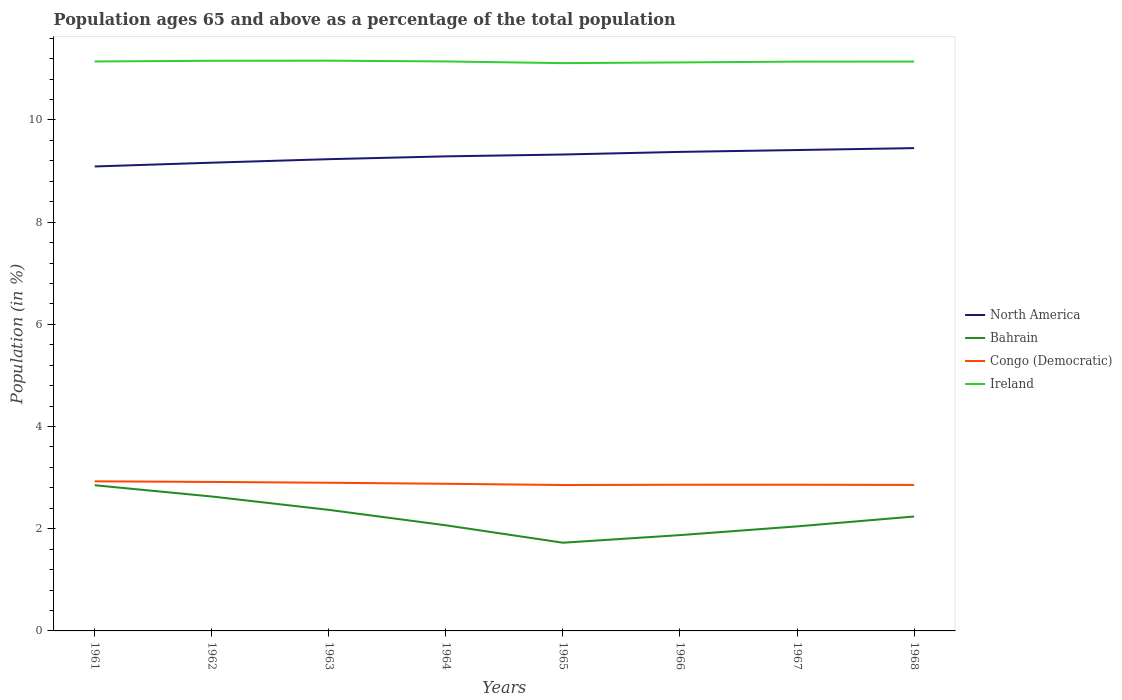Does the line corresponding to Bahrain intersect with the line corresponding to North America?
Offer a terse response. No. Is the number of lines equal to the number of legend labels?
Ensure brevity in your answer.  Yes. Across all years, what is the maximum percentage of the population ages 65 and above in Bahrain?
Your answer should be very brief. 1.73. In which year was the percentage of the population ages 65 and above in Ireland maximum?
Offer a very short reply. 1965. What is the total percentage of the population ages 65 and above in Ireland in the graph?
Offer a terse response. 0.02. What is the difference between the highest and the second highest percentage of the population ages 65 and above in Congo (Democratic)?
Your response must be concise. 0.07. What is the difference between the highest and the lowest percentage of the population ages 65 and above in Ireland?
Give a very brief answer. 6. How many years are there in the graph?
Offer a very short reply. 8. Does the graph contain any zero values?
Offer a terse response. No. How are the legend labels stacked?
Ensure brevity in your answer.  Vertical. What is the title of the graph?
Offer a terse response. Population ages 65 and above as a percentage of the total population. Does "Spain" appear as one of the legend labels in the graph?
Offer a terse response. No. What is the Population (in %) in North America in 1961?
Give a very brief answer. 9.09. What is the Population (in %) of Bahrain in 1961?
Provide a short and direct response. 2.85. What is the Population (in %) of Congo (Democratic) in 1961?
Give a very brief answer. 2.93. What is the Population (in %) of Ireland in 1961?
Provide a short and direct response. 11.14. What is the Population (in %) of North America in 1962?
Your response must be concise. 9.16. What is the Population (in %) in Bahrain in 1962?
Offer a very short reply. 2.63. What is the Population (in %) in Congo (Democratic) in 1962?
Ensure brevity in your answer.  2.92. What is the Population (in %) in Ireland in 1962?
Offer a very short reply. 11.16. What is the Population (in %) in North America in 1963?
Offer a very short reply. 9.23. What is the Population (in %) of Bahrain in 1963?
Your answer should be very brief. 2.37. What is the Population (in %) of Congo (Democratic) in 1963?
Offer a terse response. 2.9. What is the Population (in %) of Ireland in 1963?
Give a very brief answer. 11.16. What is the Population (in %) of North America in 1964?
Make the answer very short. 9.29. What is the Population (in %) in Bahrain in 1964?
Provide a short and direct response. 2.07. What is the Population (in %) of Congo (Democratic) in 1964?
Your answer should be compact. 2.88. What is the Population (in %) in Ireland in 1964?
Your answer should be compact. 11.15. What is the Population (in %) of North America in 1965?
Your answer should be compact. 9.32. What is the Population (in %) of Bahrain in 1965?
Your answer should be compact. 1.73. What is the Population (in %) of Congo (Democratic) in 1965?
Keep it short and to the point. 2.86. What is the Population (in %) of Ireland in 1965?
Make the answer very short. 11.11. What is the Population (in %) in North America in 1966?
Keep it short and to the point. 9.38. What is the Population (in %) of Bahrain in 1966?
Keep it short and to the point. 1.88. What is the Population (in %) in Congo (Democratic) in 1966?
Your answer should be compact. 2.86. What is the Population (in %) in Ireland in 1966?
Keep it short and to the point. 11.13. What is the Population (in %) of North America in 1967?
Provide a short and direct response. 9.41. What is the Population (in %) of Bahrain in 1967?
Offer a terse response. 2.05. What is the Population (in %) of Congo (Democratic) in 1967?
Offer a very short reply. 2.86. What is the Population (in %) of Ireland in 1967?
Your answer should be very brief. 11.14. What is the Population (in %) of North America in 1968?
Your response must be concise. 9.45. What is the Population (in %) in Bahrain in 1968?
Provide a short and direct response. 2.24. What is the Population (in %) of Congo (Democratic) in 1968?
Your response must be concise. 2.86. What is the Population (in %) in Ireland in 1968?
Your response must be concise. 11.14. Across all years, what is the maximum Population (in %) in North America?
Give a very brief answer. 9.45. Across all years, what is the maximum Population (in %) in Bahrain?
Give a very brief answer. 2.85. Across all years, what is the maximum Population (in %) in Congo (Democratic)?
Your answer should be very brief. 2.93. Across all years, what is the maximum Population (in %) in Ireland?
Offer a very short reply. 11.16. Across all years, what is the minimum Population (in %) in North America?
Offer a terse response. 9.09. Across all years, what is the minimum Population (in %) in Bahrain?
Your answer should be very brief. 1.73. Across all years, what is the minimum Population (in %) in Congo (Democratic)?
Provide a short and direct response. 2.86. Across all years, what is the minimum Population (in %) of Ireland?
Your response must be concise. 11.11. What is the total Population (in %) in North America in the graph?
Your answer should be compact. 74.33. What is the total Population (in %) of Bahrain in the graph?
Make the answer very short. 17.8. What is the total Population (in %) in Congo (Democratic) in the graph?
Provide a succinct answer. 23.06. What is the total Population (in %) of Ireland in the graph?
Your answer should be very brief. 89.13. What is the difference between the Population (in %) of North America in 1961 and that in 1962?
Provide a succinct answer. -0.07. What is the difference between the Population (in %) of Bahrain in 1961 and that in 1962?
Make the answer very short. 0.22. What is the difference between the Population (in %) in Congo (Democratic) in 1961 and that in 1962?
Give a very brief answer. 0.01. What is the difference between the Population (in %) in Ireland in 1961 and that in 1962?
Your response must be concise. -0.01. What is the difference between the Population (in %) in North America in 1961 and that in 1963?
Your answer should be very brief. -0.14. What is the difference between the Population (in %) of Bahrain in 1961 and that in 1963?
Provide a succinct answer. 0.48. What is the difference between the Population (in %) of Congo (Democratic) in 1961 and that in 1963?
Ensure brevity in your answer.  0.03. What is the difference between the Population (in %) in Ireland in 1961 and that in 1963?
Offer a terse response. -0.02. What is the difference between the Population (in %) in North America in 1961 and that in 1964?
Offer a terse response. -0.2. What is the difference between the Population (in %) of Bahrain in 1961 and that in 1964?
Give a very brief answer. 0.78. What is the difference between the Population (in %) of Congo (Democratic) in 1961 and that in 1964?
Ensure brevity in your answer.  0.05. What is the difference between the Population (in %) in Ireland in 1961 and that in 1964?
Provide a short and direct response. -0. What is the difference between the Population (in %) of North America in 1961 and that in 1965?
Your answer should be compact. -0.23. What is the difference between the Population (in %) in Bahrain in 1961 and that in 1965?
Offer a terse response. 1.13. What is the difference between the Population (in %) of Congo (Democratic) in 1961 and that in 1965?
Provide a short and direct response. 0.07. What is the difference between the Population (in %) of Ireland in 1961 and that in 1965?
Keep it short and to the point. 0.03. What is the difference between the Population (in %) of North America in 1961 and that in 1966?
Ensure brevity in your answer.  -0.29. What is the difference between the Population (in %) of Bahrain in 1961 and that in 1966?
Keep it short and to the point. 0.98. What is the difference between the Population (in %) of Congo (Democratic) in 1961 and that in 1966?
Your answer should be compact. 0.07. What is the difference between the Population (in %) in Ireland in 1961 and that in 1966?
Give a very brief answer. 0.02. What is the difference between the Population (in %) in North America in 1961 and that in 1967?
Your answer should be very brief. -0.32. What is the difference between the Population (in %) in Bahrain in 1961 and that in 1967?
Provide a short and direct response. 0.81. What is the difference between the Population (in %) in Congo (Democratic) in 1961 and that in 1967?
Keep it short and to the point. 0.07. What is the difference between the Population (in %) in Ireland in 1961 and that in 1967?
Offer a very short reply. 0. What is the difference between the Population (in %) in North America in 1961 and that in 1968?
Your response must be concise. -0.36. What is the difference between the Population (in %) of Bahrain in 1961 and that in 1968?
Provide a succinct answer. 0.61. What is the difference between the Population (in %) in Congo (Democratic) in 1961 and that in 1968?
Offer a very short reply. 0.07. What is the difference between the Population (in %) in Ireland in 1961 and that in 1968?
Offer a very short reply. 0. What is the difference between the Population (in %) in North America in 1962 and that in 1963?
Provide a short and direct response. -0.07. What is the difference between the Population (in %) in Bahrain in 1962 and that in 1963?
Your answer should be compact. 0.26. What is the difference between the Population (in %) in Congo (Democratic) in 1962 and that in 1963?
Your answer should be compact. 0.02. What is the difference between the Population (in %) of Ireland in 1962 and that in 1963?
Your answer should be very brief. -0. What is the difference between the Population (in %) of North America in 1962 and that in 1964?
Give a very brief answer. -0.12. What is the difference between the Population (in %) in Bahrain in 1962 and that in 1964?
Make the answer very short. 0.56. What is the difference between the Population (in %) in Congo (Democratic) in 1962 and that in 1964?
Offer a terse response. 0.04. What is the difference between the Population (in %) in Ireland in 1962 and that in 1964?
Make the answer very short. 0.01. What is the difference between the Population (in %) of North America in 1962 and that in 1965?
Offer a terse response. -0.16. What is the difference between the Population (in %) of Bahrain in 1962 and that in 1965?
Your answer should be very brief. 0.9. What is the difference between the Population (in %) in Congo (Democratic) in 1962 and that in 1965?
Give a very brief answer. 0.06. What is the difference between the Population (in %) of Ireland in 1962 and that in 1965?
Keep it short and to the point. 0.05. What is the difference between the Population (in %) of North America in 1962 and that in 1966?
Your answer should be compact. -0.21. What is the difference between the Population (in %) of Bahrain in 1962 and that in 1966?
Keep it short and to the point. 0.76. What is the difference between the Population (in %) of Congo (Democratic) in 1962 and that in 1966?
Ensure brevity in your answer.  0.06. What is the difference between the Population (in %) in Ireland in 1962 and that in 1966?
Make the answer very short. 0.03. What is the difference between the Population (in %) in North America in 1962 and that in 1967?
Make the answer very short. -0.25. What is the difference between the Population (in %) of Bahrain in 1962 and that in 1967?
Your answer should be compact. 0.58. What is the difference between the Population (in %) of Congo (Democratic) in 1962 and that in 1967?
Provide a succinct answer. 0.05. What is the difference between the Population (in %) of Ireland in 1962 and that in 1967?
Make the answer very short. 0.02. What is the difference between the Population (in %) in North America in 1962 and that in 1968?
Your response must be concise. -0.29. What is the difference between the Population (in %) of Bahrain in 1962 and that in 1968?
Your answer should be very brief. 0.39. What is the difference between the Population (in %) of Congo (Democratic) in 1962 and that in 1968?
Offer a terse response. 0.06. What is the difference between the Population (in %) in Ireland in 1962 and that in 1968?
Offer a very short reply. 0.02. What is the difference between the Population (in %) in North America in 1963 and that in 1964?
Provide a short and direct response. -0.06. What is the difference between the Population (in %) in Bahrain in 1963 and that in 1964?
Offer a terse response. 0.3. What is the difference between the Population (in %) of Congo (Democratic) in 1963 and that in 1964?
Your response must be concise. 0.02. What is the difference between the Population (in %) in Ireland in 1963 and that in 1964?
Your response must be concise. 0.01. What is the difference between the Population (in %) in North America in 1963 and that in 1965?
Make the answer very short. -0.09. What is the difference between the Population (in %) in Bahrain in 1963 and that in 1965?
Your answer should be compact. 0.64. What is the difference between the Population (in %) in Congo (Democratic) in 1963 and that in 1965?
Your response must be concise. 0.04. What is the difference between the Population (in %) in Ireland in 1963 and that in 1965?
Provide a short and direct response. 0.05. What is the difference between the Population (in %) of North America in 1963 and that in 1966?
Your answer should be compact. -0.14. What is the difference between the Population (in %) of Bahrain in 1963 and that in 1966?
Provide a succinct answer. 0.49. What is the difference between the Population (in %) in Congo (Democratic) in 1963 and that in 1966?
Give a very brief answer. 0.04. What is the difference between the Population (in %) of Ireland in 1963 and that in 1966?
Your response must be concise. 0.03. What is the difference between the Population (in %) of North America in 1963 and that in 1967?
Your response must be concise. -0.18. What is the difference between the Population (in %) of Bahrain in 1963 and that in 1967?
Make the answer very short. 0.32. What is the difference between the Population (in %) in Congo (Democratic) in 1963 and that in 1967?
Make the answer very short. 0.04. What is the difference between the Population (in %) of Ireland in 1963 and that in 1967?
Ensure brevity in your answer.  0.02. What is the difference between the Population (in %) in North America in 1963 and that in 1968?
Your response must be concise. -0.22. What is the difference between the Population (in %) of Bahrain in 1963 and that in 1968?
Your answer should be very brief. 0.13. What is the difference between the Population (in %) of Congo (Democratic) in 1963 and that in 1968?
Provide a succinct answer. 0.04. What is the difference between the Population (in %) in Ireland in 1963 and that in 1968?
Provide a short and direct response. 0.02. What is the difference between the Population (in %) in North America in 1964 and that in 1965?
Give a very brief answer. -0.04. What is the difference between the Population (in %) in Bahrain in 1964 and that in 1965?
Your answer should be compact. 0.34. What is the difference between the Population (in %) in Congo (Democratic) in 1964 and that in 1965?
Give a very brief answer. 0.02. What is the difference between the Population (in %) in Ireland in 1964 and that in 1965?
Keep it short and to the point. 0.03. What is the difference between the Population (in %) in North America in 1964 and that in 1966?
Give a very brief answer. -0.09. What is the difference between the Population (in %) of Bahrain in 1964 and that in 1966?
Ensure brevity in your answer.  0.19. What is the difference between the Population (in %) of Congo (Democratic) in 1964 and that in 1966?
Provide a short and direct response. 0.02. What is the difference between the Population (in %) in Ireland in 1964 and that in 1966?
Offer a very short reply. 0.02. What is the difference between the Population (in %) of North America in 1964 and that in 1967?
Your response must be concise. -0.12. What is the difference between the Population (in %) in Bahrain in 1964 and that in 1967?
Your answer should be very brief. 0.02. What is the difference between the Population (in %) in Congo (Democratic) in 1964 and that in 1967?
Offer a very short reply. 0.02. What is the difference between the Population (in %) in Ireland in 1964 and that in 1967?
Keep it short and to the point. 0. What is the difference between the Population (in %) in North America in 1964 and that in 1968?
Give a very brief answer. -0.16. What is the difference between the Population (in %) of Bahrain in 1964 and that in 1968?
Provide a short and direct response. -0.17. What is the difference between the Population (in %) in Congo (Democratic) in 1964 and that in 1968?
Offer a very short reply. 0.02. What is the difference between the Population (in %) in Ireland in 1964 and that in 1968?
Offer a very short reply. 0. What is the difference between the Population (in %) in North America in 1965 and that in 1966?
Give a very brief answer. -0.05. What is the difference between the Population (in %) in Bahrain in 1965 and that in 1966?
Provide a short and direct response. -0.15. What is the difference between the Population (in %) of Congo (Democratic) in 1965 and that in 1966?
Ensure brevity in your answer.  -0.01. What is the difference between the Population (in %) of Ireland in 1965 and that in 1966?
Provide a succinct answer. -0.01. What is the difference between the Population (in %) of North America in 1965 and that in 1967?
Give a very brief answer. -0.09. What is the difference between the Population (in %) in Bahrain in 1965 and that in 1967?
Ensure brevity in your answer.  -0.32. What is the difference between the Population (in %) of Congo (Democratic) in 1965 and that in 1967?
Offer a very short reply. -0.01. What is the difference between the Population (in %) of Ireland in 1965 and that in 1967?
Your answer should be compact. -0.03. What is the difference between the Population (in %) of North America in 1965 and that in 1968?
Keep it short and to the point. -0.13. What is the difference between the Population (in %) of Bahrain in 1965 and that in 1968?
Offer a terse response. -0.51. What is the difference between the Population (in %) of Congo (Democratic) in 1965 and that in 1968?
Give a very brief answer. -0. What is the difference between the Population (in %) in Ireland in 1965 and that in 1968?
Ensure brevity in your answer.  -0.03. What is the difference between the Population (in %) of North America in 1966 and that in 1967?
Offer a very short reply. -0.04. What is the difference between the Population (in %) in Bahrain in 1966 and that in 1967?
Offer a very short reply. -0.17. What is the difference between the Population (in %) of Congo (Democratic) in 1966 and that in 1967?
Ensure brevity in your answer.  -0. What is the difference between the Population (in %) in Ireland in 1966 and that in 1967?
Provide a succinct answer. -0.02. What is the difference between the Population (in %) of North America in 1966 and that in 1968?
Keep it short and to the point. -0.07. What is the difference between the Population (in %) in Bahrain in 1966 and that in 1968?
Your answer should be very brief. -0.36. What is the difference between the Population (in %) in Congo (Democratic) in 1966 and that in 1968?
Provide a short and direct response. 0. What is the difference between the Population (in %) of Ireland in 1966 and that in 1968?
Your answer should be very brief. -0.02. What is the difference between the Population (in %) in North America in 1967 and that in 1968?
Your answer should be compact. -0.04. What is the difference between the Population (in %) in Bahrain in 1967 and that in 1968?
Offer a very short reply. -0.19. What is the difference between the Population (in %) in Congo (Democratic) in 1967 and that in 1968?
Provide a short and direct response. 0. What is the difference between the Population (in %) in Ireland in 1967 and that in 1968?
Your response must be concise. -0. What is the difference between the Population (in %) of North America in 1961 and the Population (in %) of Bahrain in 1962?
Your response must be concise. 6.46. What is the difference between the Population (in %) in North America in 1961 and the Population (in %) in Congo (Democratic) in 1962?
Make the answer very short. 6.17. What is the difference between the Population (in %) of North America in 1961 and the Population (in %) of Ireland in 1962?
Provide a short and direct response. -2.07. What is the difference between the Population (in %) of Bahrain in 1961 and the Population (in %) of Congo (Democratic) in 1962?
Make the answer very short. -0.06. What is the difference between the Population (in %) in Bahrain in 1961 and the Population (in %) in Ireland in 1962?
Keep it short and to the point. -8.31. What is the difference between the Population (in %) in Congo (Democratic) in 1961 and the Population (in %) in Ireland in 1962?
Provide a short and direct response. -8.23. What is the difference between the Population (in %) of North America in 1961 and the Population (in %) of Bahrain in 1963?
Provide a succinct answer. 6.72. What is the difference between the Population (in %) in North America in 1961 and the Population (in %) in Congo (Democratic) in 1963?
Ensure brevity in your answer.  6.19. What is the difference between the Population (in %) of North America in 1961 and the Population (in %) of Ireland in 1963?
Ensure brevity in your answer.  -2.07. What is the difference between the Population (in %) in Bahrain in 1961 and the Population (in %) in Congo (Democratic) in 1963?
Offer a very short reply. -0.05. What is the difference between the Population (in %) in Bahrain in 1961 and the Population (in %) in Ireland in 1963?
Offer a very short reply. -8.31. What is the difference between the Population (in %) of Congo (Democratic) in 1961 and the Population (in %) of Ireland in 1963?
Ensure brevity in your answer.  -8.23. What is the difference between the Population (in %) in North America in 1961 and the Population (in %) in Bahrain in 1964?
Make the answer very short. 7.02. What is the difference between the Population (in %) in North America in 1961 and the Population (in %) in Congo (Democratic) in 1964?
Make the answer very short. 6.21. What is the difference between the Population (in %) in North America in 1961 and the Population (in %) in Ireland in 1964?
Offer a terse response. -2.06. What is the difference between the Population (in %) in Bahrain in 1961 and the Population (in %) in Congo (Democratic) in 1964?
Provide a succinct answer. -0.03. What is the difference between the Population (in %) of Bahrain in 1961 and the Population (in %) of Ireland in 1964?
Keep it short and to the point. -8.29. What is the difference between the Population (in %) of Congo (Democratic) in 1961 and the Population (in %) of Ireland in 1964?
Make the answer very short. -8.22. What is the difference between the Population (in %) in North America in 1961 and the Population (in %) in Bahrain in 1965?
Your answer should be very brief. 7.36. What is the difference between the Population (in %) in North America in 1961 and the Population (in %) in Congo (Democratic) in 1965?
Offer a very short reply. 6.23. What is the difference between the Population (in %) in North America in 1961 and the Population (in %) in Ireland in 1965?
Make the answer very short. -2.02. What is the difference between the Population (in %) of Bahrain in 1961 and the Population (in %) of Congo (Democratic) in 1965?
Offer a very short reply. -0. What is the difference between the Population (in %) in Bahrain in 1961 and the Population (in %) in Ireland in 1965?
Give a very brief answer. -8.26. What is the difference between the Population (in %) in Congo (Democratic) in 1961 and the Population (in %) in Ireland in 1965?
Provide a short and direct response. -8.18. What is the difference between the Population (in %) in North America in 1961 and the Population (in %) in Bahrain in 1966?
Your response must be concise. 7.21. What is the difference between the Population (in %) of North America in 1961 and the Population (in %) of Congo (Democratic) in 1966?
Keep it short and to the point. 6.23. What is the difference between the Population (in %) of North America in 1961 and the Population (in %) of Ireland in 1966?
Offer a terse response. -2.04. What is the difference between the Population (in %) in Bahrain in 1961 and the Population (in %) in Congo (Democratic) in 1966?
Provide a succinct answer. -0.01. What is the difference between the Population (in %) of Bahrain in 1961 and the Population (in %) of Ireland in 1966?
Provide a succinct answer. -8.27. What is the difference between the Population (in %) in Congo (Democratic) in 1961 and the Population (in %) in Ireland in 1966?
Your answer should be very brief. -8.2. What is the difference between the Population (in %) of North America in 1961 and the Population (in %) of Bahrain in 1967?
Provide a short and direct response. 7.04. What is the difference between the Population (in %) in North America in 1961 and the Population (in %) in Congo (Democratic) in 1967?
Your response must be concise. 6.23. What is the difference between the Population (in %) of North America in 1961 and the Population (in %) of Ireland in 1967?
Provide a short and direct response. -2.05. What is the difference between the Population (in %) in Bahrain in 1961 and the Population (in %) in Congo (Democratic) in 1967?
Provide a succinct answer. -0.01. What is the difference between the Population (in %) in Bahrain in 1961 and the Population (in %) in Ireland in 1967?
Your answer should be very brief. -8.29. What is the difference between the Population (in %) of Congo (Democratic) in 1961 and the Population (in %) of Ireland in 1967?
Your answer should be compact. -8.21. What is the difference between the Population (in %) of North America in 1961 and the Population (in %) of Bahrain in 1968?
Keep it short and to the point. 6.85. What is the difference between the Population (in %) of North America in 1961 and the Population (in %) of Congo (Democratic) in 1968?
Ensure brevity in your answer.  6.23. What is the difference between the Population (in %) of North America in 1961 and the Population (in %) of Ireland in 1968?
Offer a very short reply. -2.05. What is the difference between the Population (in %) in Bahrain in 1961 and the Population (in %) in Congo (Democratic) in 1968?
Keep it short and to the point. -0.01. What is the difference between the Population (in %) of Bahrain in 1961 and the Population (in %) of Ireland in 1968?
Offer a terse response. -8.29. What is the difference between the Population (in %) of Congo (Democratic) in 1961 and the Population (in %) of Ireland in 1968?
Offer a very short reply. -8.21. What is the difference between the Population (in %) in North America in 1962 and the Population (in %) in Bahrain in 1963?
Offer a very short reply. 6.79. What is the difference between the Population (in %) in North America in 1962 and the Population (in %) in Congo (Democratic) in 1963?
Offer a terse response. 6.26. What is the difference between the Population (in %) of North America in 1962 and the Population (in %) of Ireland in 1963?
Your response must be concise. -2. What is the difference between the Population (in %) in Bahrain in 1962 and the Population (in %) in Congo (Democratic) in 1963?
Keep it short and to the point. -0.27. What is the difference between the Population (in %) in Bahrain in 1962 and the Population (in %) in Ireland in 1963?
Make the answer very short. -8.53. What is the difference between the Population (in %) of Congo (Democratic) in 1962 and the Population (in %) of Ireland in 1963?
Your answer should be very brief. -8.24. What is the difference between the Population (in %) of North America in 1962 and the Population (in %) of Bahrain in 1964?
Make the answer very short. 7.1. What is the difference between the Population (in %) in North America in 1962 and the Population (in %) in Congo (Democratic) in 1964?
Your response must be concise. 6.28. What is the difference between the Population (in %) in North America in 1962 and the Population (in %) in Ireland in 1964?
Your response must be concise. -1.98. What is the difference between the Population (in %) of Bahrain in 1962 and the Population (in %) of Congo (Democratic) in 1964?
Ensure brevity in your answer.  -0.25. What is the difference between the Population (in %) in Bahrain in 1962 and the Population (in %) in Ireland in 1964?
Ensure brevity in your answer.  -8.51. What is the difference between the Population (in %) in Congo (Democratic) in 1962 and the Population (in %) in Ireland in 1964?
Offer a terse response. -8.23. What is the difference between the Population (in %) in North America in 1962 and the Population (in %) in Bahrain in 1965?
Keep it short and to the point. 7.44. What is the difference between the Population (in %) in North America in 1962 and the Population (in %) in Congo (Democratic) in 1965?
Offer a terse response. 6.31. What is the difference between the Population (in %) of North America in 1962 and the Population (in %) of Ireland in 1965?
Provide a short and direct response. -1.95. What is the difference between the Population (in %) of Bahrain in 1962 and the Population (in %) of Congo (Democratic) in 1965?
Provide a succinct answer. -0.22. What is the difference between the Population (in %) in Bahrain in 1962 and the Population (in %) in Ireland in 1965?
Your answer should be very brief. -8.48. What is the difference between the Population (in %) of Congo (Democratic) in 1962 and the Population (in %) of Ireland in 1965?
Your answer should be very brief. -8.2. What is the difference between the Population (in %) in North America in 1962 and the Population (in %) in Bahrain in 1966?
Ensure brevity in your answer.  7.29. What is the difference between the Population (in %) in North America in 1962 and the Population (in %) in Congo (Democratic) in 1966?
Ensure brevity in your answer.  6.3. What is the difference between the Population (in %) of North America in 1962 and the Population (in %) of Ireland in 1966?
Your response must be concise. -1.96. What is the difference between the Population (in %) of Bahrain in 1962 and the Population (in %) of Congo (Democratic) in 1966?
Make the answer very short. -0.23. What is the difference between the Population (in %) of Bahrain in 1962 and the Population (in %) of Ireland in 1966?
Offer a very short reply. -8.5. What is the difference between the Population (in %) of Congo (Democratic) in 1962 and the Population (in %) of Ireland in 1966?
Provide a short and direct response. -8.21. What is the difference between the Population (in %) of North America in 1962 and the Population (in %) of Bahrain in 1967?
Ensure brevity in your answer.  7.12. What is the difference between the Population (in %) in North America in 1962 and the Population (in %) in Congo (Democratic) in 1967?
Offer a terse response. 6.3. What is the difference between the Population (in %) of North America in 1962 and the Population (in %) of Ireland in 1967?
Provide a short and direct response. -1.98. What is the difference between the Population (in %) in Bahrain in 1962 and the Population (in %) in Congo (Democratic) in 1967?
Provide a short and direct response. -0.23. What is the difference between the Population (in %) of Bahrain in 1962 and the Population (in %) of Ireland in 1967?
Keep it short and to the point. -8.51. What is the difference between the Population (in %) of Congo (Democratic) in 1962 and the Population (in %) of Ireland in 1967?
Ensure brevity in your answer.  -8.23. What is the difference between the Population (in %) of North America in 1962 and the Population (in %) of Bahrain in 1968?
Make the answer very short. 6.92. What is the difference between the Population (in %) in North America in 1962 and the Population (in %) in Congo (Democratic) in 1968?
Make the answer very short. 6.31. What is the difference between the Population (in %) in North America in 1962 and the Population (in %) in Ireland in 1968?
Provide a succinct answer. -1.98. What is the difference between the Population (in %) of Bahrain in 1962 and the Population (in %) of Congo (Democratic) in 1968?
Make the answer very short. -0.23. What is the difference between the Population (in %) in Bahrain in 1962 and the Population (in %) in Ireland in 1968?
Make the answer very short. -8.51. What is the difference between the Population (in %) of Congo (Democratic) in 1962 and the Population (in %) of Ireland in 1968?
Provide a succinct answer. -8.23. What is the difference between the Population (in %) of North America in 1963 and the Population (in %) of Bahrain in 1964?
Your answer should be compact. 7.17. What is the difference between the Population (in %) of North America in 1963 and the Population (in %) of Congo (Democratic) in 1964?
Ensure brevity in your answer.  6.35. What is the difference between the Population (in %) in North America in 1963 and the Population (in %) in Ireland in 1964?
Your answer should be compact. -1.91. What is the difference between the Population (in %) of Bahrain in 1963 and the Population (in %) of Congo (Democratic) in 1964?
Give a very brief answer. -0.51. What is the difference between the Population (in %) in Bahrain in 1963 and the Population (in %) in Ireland in 1964?
Offer a terse response. -8.78. What is the difference between the Population (in %) in Congo (Democratic) in 1963 and the Population (in %) in Ireland in 1964?
Give a very brief answer. -8.25. What is the difference between the Population (in %) of North America in 1963 and the Population (in %) of Bahrain in 1965?
Make the answer very short. 7.51. What is the difference between the Population (in %) of North America in 1963 and the Population (in %) of Congo (Democratic) in 1965?
Offer a terse response. 6.38. What is the difference between the Population (in %) of North America in 1963 and the Population (in %) of Ireland in 1965?
Provide a succinct answer. -1.88. What is the difference between the Population (in %) in Bahrain in 1963 and the Population (in %) in Congo (Democratic) in 1965?
Keep it short and to the point. -0.49. What is the difference between the Population (in %) of Bahrain in 1963 and the Population (in %) of Ireland in 1965?
Offer a very short reply. -8.74. What is the difference between the Population (in %) of Congo (Democratic) in 1963 and the Population (in %) of Ireland in 1965?
Your response must be concise. -8.21. What is the difference between the Population (in %) of North America in 1963 and the Population (in %) of Bahrain in 1966?
Offer a terse response. 7.36. What is the difference between the Population (in %) of North America in 1963 and the Population (in %) of Congo (Democratic) in 1966?
Keep it short and to the point. 6.37. What is the difference between the Population (in %) of North America in 1963 and the Population (in %) of Ireland in 1966?
Keep it short and to the point. -1.89. What is the difference between the Population (in %) in Bahrain in 1963 and the Population (in %) in Congo (Democratic) in 1966?
Ensure brevity in your answer.  -0.49. What is the difference between the Population (in %) in Bahrain in 1963 and the Population (in %) in Ireland in 1966?
Provide a short and direct response. -8.76. What is the difference between the Population (in %) of Congo (Democratic) in 1963 and the Population (in %) of Ireland in 1966?
Provide a short and direct response. -8.23. What is the difference between the Population (in %) of North America in 1963 and the Population (in %) of Bahrain in 1967?
Your answer should be compact. 7.19. What is the difference between the Population (in %) in North America in 1963 and the Population (in %) in Congo (Democratic) in 1967?
Make the answer very short. 6.37. What is the difference between the Population (in %) in North America in 1963 and the Population (in %) in Ireland in 1967?
Make the answer very short. -1.91. What is the difference between the Population (in %) in Bahrain in 1963 and the Population (in %) in Congo (Democratic) in 1967?
Your response must be concise. -0.49. What is the difference between the Population (in %) of Bahrain in 1963 and the Population (in %) of Ireland in 1967?
Offer a very short reply. -8.77. What is the difference between the Population (in %) of Congo (Democratic) in 1963 and the Population (in %) of Ireland in 1967?
Make the answer very short. -8.24. What is the difference between the Population (in %) in North America in 1963 and the Population (in %) in Bahrain in 1968?
Offer a very short reply. 6.99. What is the difference between the Population (in %) of North America in 1963 and the Population (in %) of Congo (Democratic) in 1968?
Your response must be concise. 6.38. What is the difference between the Population (in %) in North America in 1963 and the Population (in %) in Ireland in 1968?
Your answer should be compact. -1.91. What is the difference between the Population (in %) of Bahrain in 1963 and the Population (in %) of Congo (Democratic) in 1968?
Provide a short and direct response. -0.49. What is the difference between the Population (in %) in Bahrain in 1963 and the Population (in %) in Ireland in 1968?
Provide a short and direct response. -8.77. What is the difference between the Population (in %) in Congo (Democratic) in 1963 and the Population (in %) in Ireland in 1968?
Give a very brief answer. -8.24. What is the difference between the Population (in %) of North America in 1964 and the Population (in %) of Bahrain in 1965?
Offer a very short reply. 7.56. What is the difference between the Population (in %) in North America in 1964 and the Population (in %) in Congo (Democratic) in 1965?
Make the answer very short. 6.43. What is the difference between the Population (in %) in North America in 1964 and the Population (in %) in Ireland in 1965?
Provide a short and direct response. -1.82. What is the difference between the Population (in %) in Bahrain in 1964 and the Population (in %) in Congo (Democratic) in 1965?
Your response must be concise. -0.79. What is the difference between the Population (in %) of Bahrain in 1964 and the Population (in %) of Ireland in 1965?
Your answer should be compact. -9.04. What is the difference between the Population (in %) in Congo (Democratic) in 1964 and the Population (in %) in Ireland in 1965?
Provide a short and direct response. -8.23. What is the difference between the Population (in %) in North America in 1964 and the Population (in %) in Bahrain in 1966?
Offer a very short reply. 7.41. What is the difference between the Population (in %) in North America in 1964 and the Population (in %) in Congo (Democratic) in 1966?
Your response must be concise. 6.43. What is the difference between the Population (in %) in North America in 1964 and the Population (in %) in Ireland in 1966?
Offer a terse response. -1.84. What is the difference between the Population (in %) in Bahrain in 1964 and the Population (in %) in Congo (Democratic) in 1966?
Give a very brief answer. -0.79. What is the difference between the Population (in %) of Bahrain in 1964 and the Population (in %) of Ireland in 1966?
Your answer should be very brief. -9.06. What is the difference between the Population (in %) of Congo (Democratic) in 1964 and the Population (in %) of Ireland in 1966?
Ensure brevity in your answer.  -8.25. What is the difference between the Population (in %) in North America in 1964 and the Population (in %) in Bahrain in 1967?
Offer a very short reply. 7.24. What is the difference between the Population (in %) in North America in 1964 and the Population (in %) in Congo (Democratic) in 1967?
Make the answer very short. 6.43. What is the difference between the Population (in %) of North America in 1964 and the Population (in %) of Ireland in 1967?
Give a very brief answer. -1.85. What is the difference between the Population (in %) of Bahrain in 1964 and the Population (in %) of Congo (Democratic) in 1967?
Make the answer very short. -0.79. What is the difference between the Population (in %) in Bahrain in 1964 and the Population (in %) in Ireland in 1967?
Offer a very short reply. -9.07. What is the difference between the Population (in %) in Congo (Democratic) in 1964 and the Population (in %) in Ireland in 1967?
Your answer should be compact. -8.26. What is the difference between the Population (in %) in North America in 1964 and the Population (in %) in Bahrain in 1968?
Provide a succinct answer. 7.05. What is the difference between the Population (in %) of North America in 1964 and the Population (in %) of Congo (Democratic) in 1968?
Provide a short and direct response. 6.43. What is the difference between the Population (in %) in North America in 1964 and the Population (in %) in Ireland in 1968?
Your answer should be compact. -1.85. What is the difference between the Population (in %) of Bahrain in 1964 and the Population (in %) of Congo (Democratic) in 1968?
Provide a succinct answer. -0.79. What is the difference between the Population (in %) of Bahrain in 1964 and the Population (in %) of Ireland in 1968?
Make the answer very short. -9.08. What is the difference between the Population (in %) of Congo (Democratic) in 1964 and the Population (in %) of Ireland in 1968?
Offer a very short reply. -8.26. What is the difference between the Population (in %) in North America in 1965 and the Population (in %) in Bahrain in 1966?
Offer a terse response. 7.45. What is the difference between the Population (in %) in North America in 1965 and the Population (in %) in Congo (Democratic) in 1966?
Offer a very short reply. 6.46. What is the difference between the Population (in %) of North America in 1965 and the Population (in %) of Ireland in 1966?
Make the answer very short. -1.8. What is the difference between the Population (in %) in Bahrain in 1965 and the Population (in %) in Congo (Democratic) in 1966?
Make the answer very short. -1.13. What is the difference between the Population (in %) in Bahrain in 1965 and the Population (in %) in Ireland in 1966?
Give a very brief answer. -9.4. What is the difference between the Population (in %) of Congo (Democratic) in 1965 and the Population (in %) of Ireland in 1966?
Give a very brief answer. -8.27. What is the difference between the Population (in %) in North America in 1965 and the Population (in %) in Bahrain in 1967?
Your response must be concise. 7.28. What is the difference between the Population (in %) in North America in 1965 and the Population (in %) in Congo (Democratic) in 1967?
Provide a short and direct response. 6.46. What is the difference between the Population (in %) of North America in 1965 and the Population (in %) of Ireland in 1967?
Your answer should be very brief. -1.82. What is the difference between the Population (in %) in Bahrain in 1965 and the Population (in %) in Congo (Democratic) in 1967?
Keep it short and to the point. -1.13. What is the difference between the Population (in %) in Bahrain in 1965 and the Population (in %) in Ireland in 1967?
Offer a terse response. -9.42. What is the difference between the Population (in %) in Congo (Democratic) in 1965 and the Population (in %) in Ireland in 1967?
Give a very brief answer. -8.29. What is the difference between the Population (in %) of North America in 1965 and the Population (in %) of Bahrain in 1968?
Provide a short and direct response. 7.08. What is the difference between the Population (in %) of North America in 1965 and the Population (in %) of Congo (Democratic) in 1968?
Provide a short and direct response. 6.47. What is the difference between the Population (in %) in North America in 1965 and the Population (in %) in Ireland in 1968?
Provide a short and direct response. -1.82. What is the difference between the Population (in %) in Bahrain in 1965 and the Population (in %) in Congo (Democratic) in 1968?
Your answer should be very brief. -1.13. What is the difference between the Population (in %) in Bahrain in 1965 and the Population (in %) in Ireland in 1968?
Your answer should be very brief. -9.42. What is the difference between the Population (in %) in Congo (Democratic) in 1965 and the Population (in %) in Ireland in 1968?
Give a very brief answer. -8.29. What is the difference between the Population (in %) in North America in 1966 and the Population (in %) in Bahrain in 1967?
Ensure brevity in your answer.  7.33. What is the difference between the Population (in %) in North America in 1966 and the Population (in %) in Congo (Democratic) in 1967?
Your answer should be compact. 6.51. What is the difference between the Population (in %) of North America in 1966 and the Population (in %) of Ireland in 1967?
Keep it short and to the point. -1.77. What is the difference between the Population (in %) of Bahrain in 1966 and the Population (in %) of Congo (Democratic) in 1967?
Offer a terse response. -0.99. What is the difference between the Population (in %) of Bahrain in 1966 and the Population (in %) of Ireland in 1967?
Your response must be concise. -9.27. What is the difference between the Population (in %) of Congo (Democratic) in 1966 and the Population (in %) of Ireland in 1967?
Provide a succinct answer. -8.28. What is the difference between the Population (in %) in North America in 1966 and the Population (in %) in Bahrain in 1968?
Your answer should be compact. 7.14. What is the difference between the Population (in %) of North America in 1966 and the Population (in %) of Congo (Democratic) in 1968?
Provide a succinct answer. 6.52. What is the difference between the Population (in %) of North America in 1966 and the Population (in %) of Ireland in 1968?
Offer a terse response. -1.77. What is the difference between the Population (in %) in Bahrain in 1966 and the Population (in %) in Congo (Democratic) in 1968?
Your response must be concise. -0.98. What is the difference between the Population (in %) of Bahrain in 1966 and the Population (in %) of Ireland in 1968?
Your response must be concise. -9.27. What is the difference between the Population (in %) in Congo (Democratic) in 1966 and the Population (in %) in Ireland in 1968?
Your response must be concise. -8.28. What is the difference between the Population (in %) of North America in 1967 and the Population (in %) of Bahrain in 1968?
Your answer should be compact. 7.17. What is the difference between the Population (in %) of North America in 1967 and the Population (in %) of Congo (Democratic) in 1968?
Give a very brief answer. 6.55. What is the difference between the Population (in %) in North America in 1967 and the Population (in %) in Ireland in 1968?
Make the answer very short. -1.73. What is the difference between the Population (in %) in Bahrain in 1967 and the Population (in %) in Congo (Democratic) in 1968?
Make the answer very short. -0.81. What is the difference between the Population (in %) of Bahrain in 1967 and the Population (in %) of Ireland in 1968?
Provide a succinct answer. -9.1. What is the difference between the Population (in %) of Congo (Democratic) in 1967 and the Population (in %) of Ireland in 1968?
Offer a terse response. -8.28. What is the average Population (in %) in North America per year?
Make the answer very short. 9.29. What is the average Population (in %) of Bahrain per year?
Your answer should be compact. 2.23. What is the average Population (in %) of Congo (Democratic) per year?
Keep it short and to the point. 2.88. What is the average Population (in %) in Ireland per year?
Your answer should be compact. 11.14. In the year 1961, what is the difference between the Population (in %) of North America and Population (in %) of Bahrain?
Provide a short and direct response. 6.24. In the year 1961, what is the difference between the Population (in %) in North America and Population (in %) in Congo (Democratic)?
Provide a succinct answer. 6.16. In the year 1961, what is the difference between the Population (in %) in North America and Population (in %) in Ireland?
Provide a short and direct response. -2.05. In the year 1961, what is the difference between the Population (in %) of Bahrain and Population (in %) of Congo (Democratic)?
Your response must be concise. -0.08. In the year 1961, what is the difference between the Population (in %) of Bahrain and Population (in %) of Ireland?
Offer a terse response. -8.29. In the year 1961, what is the difference between the Population (in %) of Congo (Democratic) and Population (in %) of Ireland?
Keep it short and to the point. -8.22. In the year 1962, what is the difference between the Population (in %) of North America and Population (in %) of Bahrain?
Make the answer very short. 6.53. In the year 1962, what is the difference between the Population (in %) in North America and Population (in %) in Congo (Democratic)?
Ensure brevity in your answer.  6.25. In the year 1962, what is the difference between the Population (in %) of North America and Population (in %) of Ireland?
Ensure brevity in your answer.  -1.99. In the year 1962, what is the difference between the Population (in %) in Bahrain and Population (in %) in Congo (Democratic)?
Offer a very short reply. -0.29. In the year 1962, what is the difference between the Population (in %) in Bahrain and Population (in %) in Ireland?
Make the answer very short. -8.53. In the year 1962, what is the difference between the Population (in %) in Congo (Democratic) and Population (in %) in Ireland?
Provide a short and direct response. -8.24. In the year 1963, what is the difference between the Population (in %) in North America and Population (in %) in Bahrain?
Your answer should be very brief. 6.86. In the year 1963, what is the difference between the Population (in %) in North America and Population (in %) in Congo (Democratic)?
Provide a short and direct response. 6.33. In the year 1963, what is the difference between the Population (in %) in North America and Population (in %) in Ireland?
Give a very brief answer. -1.93. In the year 1963, what is the difference between the Population (in %) of Bahrain and Population (in %) of Congo (Democratic)?
Ensure brevity in your answer.  -0.53. In the year 1963, what is the difference between the Population (in %) of Bahrain and Population (in %) of Ireland?
Your response must be concise. -8.79. In the year 1963, what is the difference between the Population (in %) in Congo (Democratic) and Population (in %) in Ireland?
Provide a succinct answer. -8.26. In the year 1964, what is the difference between the Population (in %) in North America and Population (in %) in Bahrain?
Provide a succinct answer. 7.22. In the year 1964, what is the difference between the Population (in %) in North America and Population (in %) in Congo (Democratic)?
Your response must be concise. 6.41. In the year 1964, what is the difference between the Population (in %) in North America and Population (in %) in Ireland?
Ensure brevity in your answer.  -1.86. In the year 1964, what is the difference between the Population (in %) in Bahrain and Population (in %) in Congo (Democratic)?
Provide a succinct answer. -0.81. In the year 1964, what is the difference between the Population (in %) of Bahrain and Population (in %) of Ireland?
Your answer should be compact. -9.08. In the year 1964, what is the difference between the Population (in %) of Congo (Democratic) and Population (in %) of Ireland?
Your answer should be very brief. -8.27. In the year 1965, what is the difference between the Population (in %) of North America and Population (in %) of Bahrain?
Your answer should be compact. 7.6. In the year 1965, what is the difference between the Population (in %) in North America and Population (in %) in Congo (Democratic)?
Your response must be concise. 6.47. In the year 1965, what is the difference between the Population (in %) in North America and Population (in %) in Ireland?
Your answer should be compact. -1.79. In the year 1965, what is the difference between the Population (in %) of Bahrain and Population (in %) of Congo (Democratic)?
Provide a succinct answer. -1.13. In the year 1965, what is the difference between the Population (in %) of Bahrain and Population (in %) of Ireland?
Ensure brevity in your answer.  -9.39. In the year 1965, what is the difference between the Population (in %) in Congo (Democratic) and Population (in %) in Ireland?
Your response must be concise. -8.26. In the year 1966, what is the difference between the Population (in %) of North America and Population (in %) of Bahrain?
Provide a succinct answer. 7.5. In the year 1966, what is the difference between the Population (in %) in North America and Population (in %) in Congo (Democratic)?
Make the answer very short. 6.51. In the year 1966, what is the difference between the Population (in %) of North America and Population (in %) of Ireland?
Offer a terse response. -1.75. In the year 1966, what is the difference between the Population (in %) in Bahrain and Population (in %) in Congo (Democratic)?
Your answer should be compact. -0.99. In the year 1966, what is the difference between the Population (in %) of Bahrain and Population (in %) of Ireland?
Give a very brief answer. -9.25. In the year 1966, what is the difference between the Population (in %) in Congo (Democratic) and Population (in %) in Ireland?
Your response must be concise. -8.27. In the year 1967, what is the difference between the Population (in %) of North America and Population (in %) of Bahrain?
Offer a very short reply. 7.37. In the year 1967, what is the difference between the Population (in %) in North America and Population (in %) in Congo (Democratic)?
Your response must be concise. 6.55. In the year 1967, what is the difference between the Population (in %) of North America and Population (in %) of Ireland?
Offer a very short reply. -1.73. In the year 1967, what is the difference between the Population (in %) in Bahrain and Population (in %) in Congo (Democratic)?
Offer a very short reply. -0.82. In the year 1967, what is the difference between the Population (in %) in Bahrain and Population (in %) in Ireland?
Offer a terse response. -9.1. In the year 1967, what is the difference between the Population (in %) of Congo (Democratic) and Population (in %) of Ireland?
Ensure brevity in your answer.  -8.28. In the year 1968, what is the difference between the Population (in %) in North America and Population (in %) in Bahrain?
Keep it short and to the point. 7.21. In the year 1968, what is the difference between the Population (in %) in North America and Population (in %) in Congo (Democratic)?
Give a very brief answer. 6.59. In the year 1968, what is the difference between the Population (in %) of North America and Population (in %) of Ireland?
Offer a very short reply. -1.69. In the year 1968, what is the difference between the Population (in %) of Bahrain and Population (in %) of Congo (Democratic)?
Offer a terse response. -0.62. In the year 1968, what is the difference between the Population (in %) of Bahrain and Population (in %) of Ireland?
Keep it short and to the point. -8.9. In the year 1968, what is the difference between the Population (in %) in Congo (Democratic) and Population (in %) in Ireland?
Give a very brief answer. -8.29. What is the ratio of the Population (in %) in North America in 1961 to that in 1962?
Offer a very short reply. 0.99. What is the ratio of the Population (in %) of Bahrain in 1961 to that in 1962?
Offer a very short reply. 1.08. What is the ratio of the Population (in %) in North America in 1961 to that in 1963?
Give a very brief answer. 0.98. What is the ratio of the Population (in %) in Bahrain in 1961 to that in 1963?
Provide a short and direct response. 1.2. What is the ratio of the Population (in %) in Congo (Democratic) in 1961 to that in 1963?
Offer a terse response. 1.01. What is the ratio of the Population (in %) of Ireland in 1961 to that in 1963?
Your answer should be compact. 1. What is the ratio of the Population (in %) in North America in 1961 to that in 1964?
Provide a succinct answer. 0.98. What is the ratio of the Population (in %) in Bahrain in 1961 to that in 1964?
Offer a terse response. 1.38. What is the ratio of the Population (in %) of Congo (Democratic) in 1961 to that in 1964?
Keep it short and to the point. 1.02. What is the ratio of the Population (in %) in North America in 1961 to that in 1965?
Offer a very short reply. 0.97. What is the ratio of the Population (in %) of Bahrain in 1961 to that in 1965?
Offer a very short reply. 1.65. What is the ratio of the Population (in %) in Congo (Democratic) in 1961 to that in 1965?
Provide a succinct answer. 1.03. What is the ratio of the Population (in %) of Ireland in 1961 to that in 1965?
Your answer should be compact. 1. What is the ratio of the Population (in %) in North America in 1961 to that in 1966?
Give a very brief answer. 0.97. What is the ratio of the Population (in %) in Bahrain in 1961 to that in 1966?
Ensure brevity in your answer.  1.52. What is the ratio of the Population (in %) of Congo (Democratic) in 1961 to that in 1966?
Ensure brevity in your answer.  1.02. What is the ratio of the Population (in %) of Ireland in 1961 to that in 1966?
Give a very brief answer. 1. What is the ratio of the Population (in %) in North America in 1961 to that in 1967?
Give a very brief answer. 0.97. What is the ratio of the Population (in %) of Bahrain in 1961 to that in 1967?
Offer a very short reply. 1.39. What is the ratio of the Population (in %) of Congo (Democratic) in 1961 to that in 1967?
Provide a short and direct response. 1.02. What is the ratio of the Population (in %) in Ireland in 1961 to that in 1967?
Give a very brief answer. 1. What is the ratio of the Population (in %) in North America in 1961 to that in 1968?
Your answer should be very brief. 0.96. What is the ratio of the Population (in %) of Bahrain in 1961 to that in 1968?
Your answer should be very brief. 1.27. What is the ratio of the Population (in %) of Congo (Democratic) in 1961 to that in 1968?
Provide a succinct answer. 1.02. What is the ratio of the Population (in %) in Ireland in 1961 to that in 1968?
Provide a succinct answer. 1. What is the ratio of the Population (in %) in North America in 1962 to that in 1963?
Provide a succinct answer. 0.99. What is the ratio of the Population (in %) in Bahrain in 1962 to that in 1963?
Your answer should be very brief. 1.11. What is the ratio of the Population (in %) in Congo (Democratic) in 1962 to that in 1963?
Provide a succinct answer. 1.01. What is the ratio of the Population (in %) in Ireland in 1962 to that in 1963?
Offer a very short reply. 1. What is the ratio of the Population (in %) of North America in 1962 to that in 1964?
Your answer should be compact. 0.99. What is the ratio of the Population (in %) in Bahrain in 1962 to that in 1964?
Your answer should be very brief. 1.27. What is the ratio of the Population (in %) in Congo (Democratic) in 1962 to that in 1964?
Your answer should be compact. 1.01. What is the ratio of the Population (in %) in North America in 1962 to that in 1965?
Provide a short and direct response. 0.98. What is the ratio of the Population (in %) in Bahrain in 1962 to that in 1965?
Provide a short and direct response. 1.52. What is the ratio of the Population (in %) of Congo (Democratic) in 1962 to that in 1965?
Your response must be concise. 1.02. What is the ratio of the Population (in %) in North America in 1962 to that in 1966?
Your response must be concise. 0.98. What is the ratio of the Population (in %) in Bahrain in 1962 to that in 1966?
Make the answer very short. 1.4. What is the ratio of the Population (in %) of Congo (Democratic) in 1962 to that in 1966?
Give a very brief answer. 1.02. What is the ratio of the Population (in %) in North America in 1962 to that in 1967?
Your response must be concise. 0.97. What is the ratio of the Population (in %) of Bahrain in 1962 to that in 1967?
Give a very brief answer. 1.29. What is the ratio of the Population (in %) of Congo (Democratic) in 1962 to that in 1967?
Make the answer very short. 1.02. What is the ratio of the Population (in %) of North America in 1962 to that in 1968?
Offer a very short reply. 0.97. What is the ratio of the Population (in %) in Bahrain in 1962 to that in 1968?
Your answer should be compact. 1.17. What is the ratio of the Population (in %) of Congo (Democratic) in 1962 to that in 1968?
Your answer should be compact. 1.02. What is the ratio of the Population (in %) of Ireland in 1962 to that in 1968?
Your answer should be very brief. 1. What is the ratio of the Population (in %) in North America in 1963 to that in 1964?
Make the answer very short. 0.99. What is the ratio of the Population (in %) in Bahrain in 1963 to that in 1964?
Give a very brief answer. 1.15. What is the ratio of the Population (in %) in Congo (Democratic) in 1963 to that in 1964?
Provide a succinct answer. 1.01. What is the ratio of the Population (in %) in North America in 1963 to that in 1965?
Your answer should be very brief. 0.99. What is the ratio of the Population (in %) in Bahrain in 1963 to that in 1965?
Keep it short and to the point. 1.37. What is the ratio of the Population (in %) in Congo (Democratic) in 1963 to that in 1965?
Offer a very short reply. 1.02. What is the ratio of the Population (in %) of North America in 1963 to that in 1966?
Your answer should be very brief. 0.98. What is the ratio of the Population (in %) in Bahrain in 1963 to that in 1966?
Offer a very short reply. 1.26. What is the ratio of the Population (in %) of Congo (Democratic) in 1963 to that in 1966?
Offer a very short reply. 1.01. What is the ratio of the Population (in %) of Ireland in 1963 to that in 1966?
Your answer should be very brief. 1. What is the ratio of the Population (in %) of Bahrain in 1963 to that in 1967?
Your response must be concise. 1.16. What is the ratio of the Population (in %) in Congo (Democratic) in 1963 to that in 1967?
Your answer should be very brief. 1.01. What is the ratio of the Population (in %) in North America in 1963 to that in 1968?
Give a very brief answer. 0.98. What is the ratio of the Population (in %) of Bahrain in 1963 to that in 1968?
Provide a succinct answer. 1.06. What is the ratio of the Population (in %) in Congo (Democratic) in 1963 to that in 1968?
Keep it short and to the point. 1.01. What is the ratio of the Population (in %) of Ireland in 1963 to that in 1968?
Provide a short and direct response. 1. What is the ratio of the Population (in %) in Bahrain in 1964 to that in 1965?
Keep it short and to the point. 1.2. What is the ratio of the Population (in %) in Congo (Democratic) in 1964 to that in 1965?
Provide a succinct answer. 1.01. What is the ratio of the Population (in %) in Ireland in 1964 to that in 1965?
Give a very brief answer. 1. What is the ratio of the Population (in %) in North America in 1964 to that in 1966?
Offer a terse response. 0.99. What is the ratio of the Population (in %) in Bahrain in 1964 to that in 1966?
Ensure brevity in your answer.  1.1. What is the ratio of the Population (in %) of Congo (Democratic) in 1964 to that in 1966?
Provide a short and direct response. 1.01. What is the ratio of the Population (in %) of Ireland in 1964 to that in 1966?
Give a very brief answer. 1. What is the ratio of the Population (in %) in North America in 1964 to that in 1967?
Provide a succinct answer. 0.99. What is the ratio of the Population (in %) in Bahrain in 1964 to that in 1967?
Make the answer very short. 1.01. What is the ratio of the Population (in %) of North America in 1964 to that in 1968?
Ensure brevity in your answer.  0.98. What is the ratio of the Population (in %) in Bahrain in 1964 to that in 1968?
Your response must be concise. 0.92. What is the ratio of the Population (in %) of Congo (Democratic) in 1964 to that in 1968?
Your answer should be compact. 1.01. What is the ratio of the Population (in %) in Ireland in 1964 to that in 1968?
Your answer should be very brief. 1. What is the ratio of the Population (in %) in Bahrain in 1965 to that in 1966?
Your response must be concise. 0.92. What is the ratio of the Population (in %) in Ireland in 1965 to that in 1966?
Provide a succinct answer. 1. What is the ratio of the Population (in %) of Bahrain in 1965 to that in 1967?
Your response must be concise. 0.84. What is the ratio of the Population (in %) in Congo (Democratic) in 1965 to that in 1967?
Offer a very short reply. 1. What is the ratio of the Population (in %) of Ireland in 1965 to that in 1967?
Keep it short and to the point. 1. What is the ratio of the Population (in %) of North America in 1965 to that in 1968?
Ensure brevity in your answer.  0.99. What is the ratio of the Population (in %) in Bahrain in 1965 to that in 1968?
Your answer should be very brief. 0.77. What is the ratio of the Population (in %) in North America in 1966 to that in 1967?
Give a very brief answer. 1. What is the ratio of the Population (in %) in Bahrain in 1966 to that in 1967?
Offer a very short reply. 0.92. What is the ratio of the Population (in %) of Congo (Democratic) in 1966 to that in 1967?
Your response must be concise. 1. What is the ratio of the Population (in %) in Ireland in 1966 to that in 1967?
Provide a short and direct response. 1. What is the ratio of the Population (in %) in Bahrain in 1966 to that in 1968?
Your answer should be very brief. 0.84. What is the ratio of the Population (in %) of North America in 1967 to that in 1968?
Your answer should be compact. 1. What is the ratio of the Population (in %) of Bahrain in 1967 to that in 1968?
Your answer should be very brief. 0.91. What is the ratio of the Population (in %) in Congo (Democratic) in 1967 to that in 1968?
Ensure brevity in your answer.  1. What is the difference between the highest and the second highest Population (in %) in North America?
Your answer should be compact. 0.04. What is the difference between the highest and the second highest Population (in %) of Bahrain?
Provide a short and direct response. 0.22. What is the difference between the highest and the second highest Population (in %) in Congo (Democratic)?
Ensure brevity in your answer.  0.01. What is the difference between the highest and the second highest Population (in %) of Ireland?
Your response must be concise. 0. What is the difference between the highest and the lowest Population (in %) of North America?
Your answer should be compact. 0.36. What is the difference between the highest and the lowest Population (in %) in Bahrain?
Keep it short and to the point. 1.13. What is the difference between the highest and the lowest Population (in %) of Congo (Democratic)?
Provide a succinct answer. 0.07. What is the difference between the highest and the lowest Population (in %) of Ireland?
Your answer should be very brief. 0.05. 